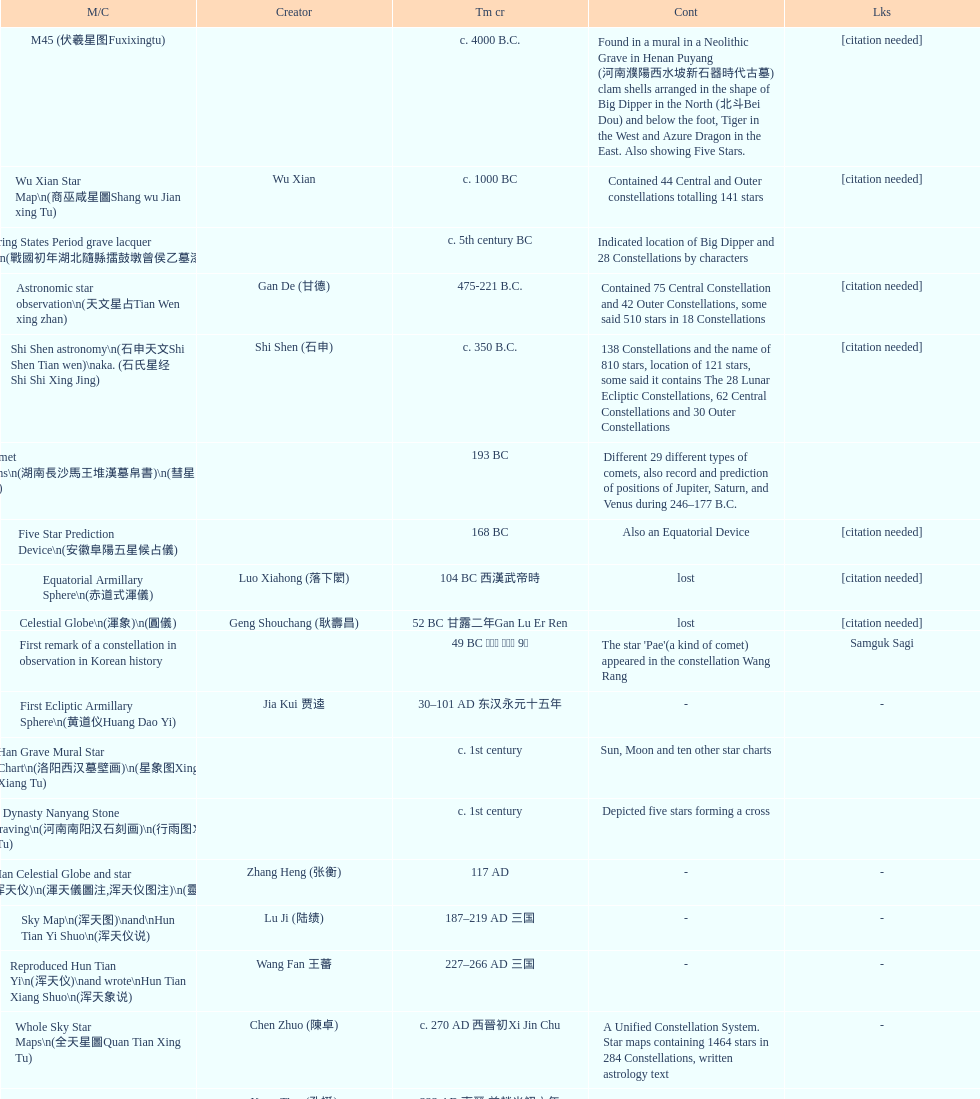Which map or catalog was created last? Sky in Google Earth KML. 